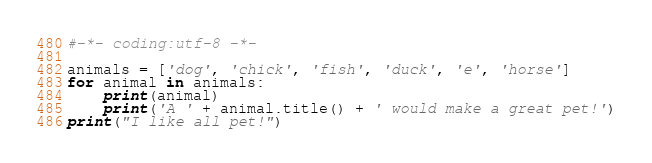Convert code to text. <code><loc_0><loc_0><loc_500><loc_500><_Python_>#-*- coding:utf-8 -*-

animals = ['dog', 'chick', 'fish', 'duck', 'e', 'horse']
for animal in animals:
    print(animal)
    print('A ' + animal.title() + ' would make a great pet!')
print("I like all pet!")</code> 